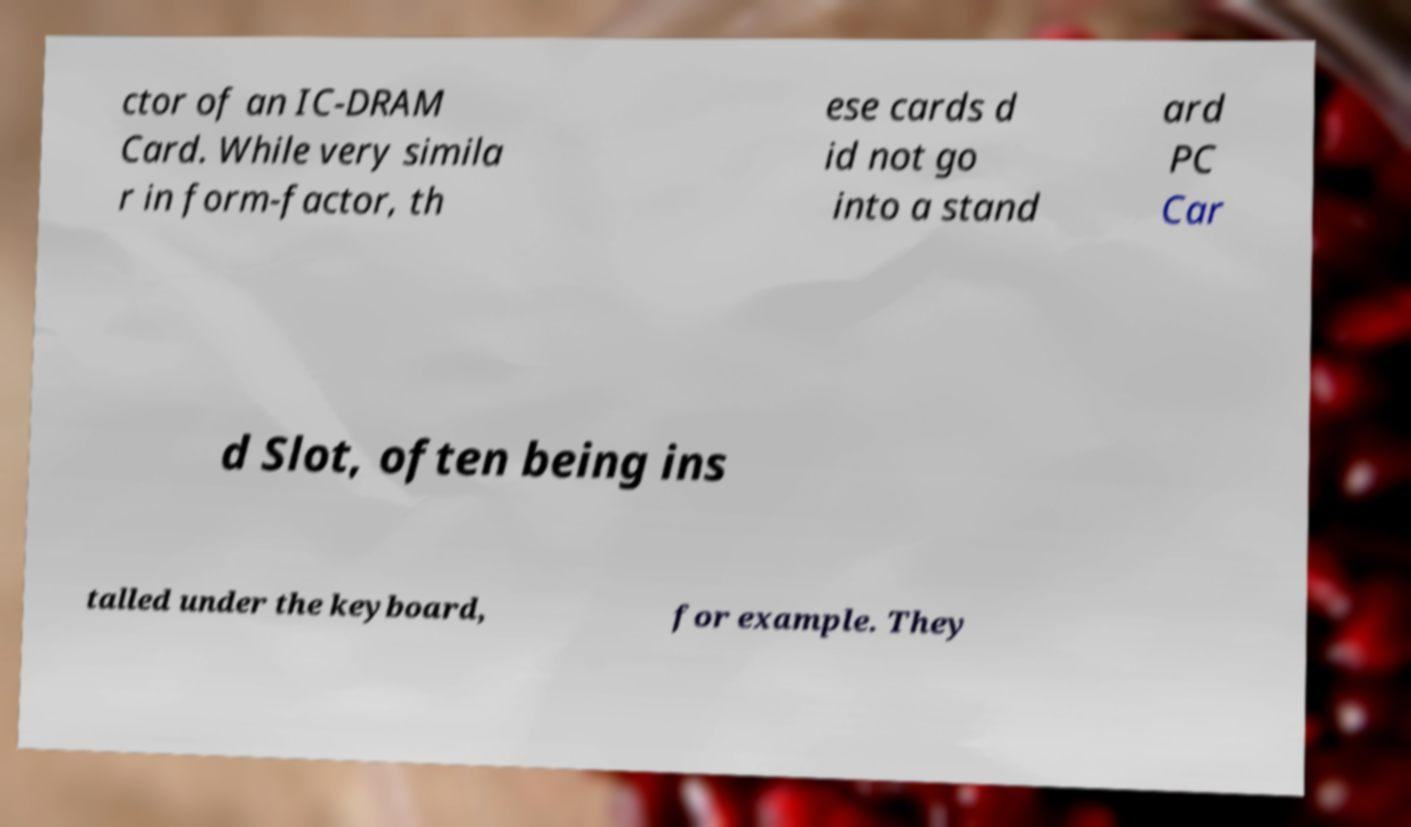Can you read and provide the text displayed in the image?This photo seems to have some interesting text. Can you extract and type it out for me? ctor of an IC-DRAM Card. While very simila r in form-factor, th ese cards d id not go into a stand ard PC Car d Slot, often being ins talled under the keyboard, for example. They 